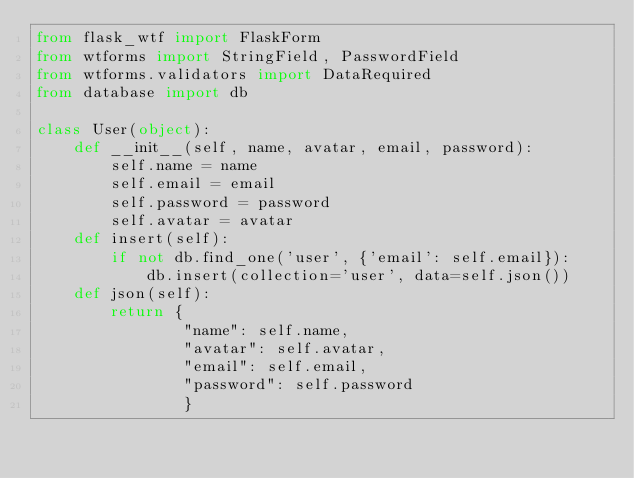<code> <loc_0><loc_0><loc_500><loc_500><_Python_>from flask_wtf import FlaskForm
from wtforms import StringField, PasswordField
from wtforms.validators import DataRequired
from database import db
 
class User(object):
    def __init__(self, name, avatar, email, password):
        self.name = name
        self.email = email
        self.password = password
        self.avatar = avatar
    def insert(self):
        if not db.find_one('user', {'email': self.email}):
            db.insert(collection='user', data=self.json())
    def json(self):
        return {
                "name": self.name,
                "avatar": self.avatar,
                "email": self.email,
                "password": self.password
                }
</code> 